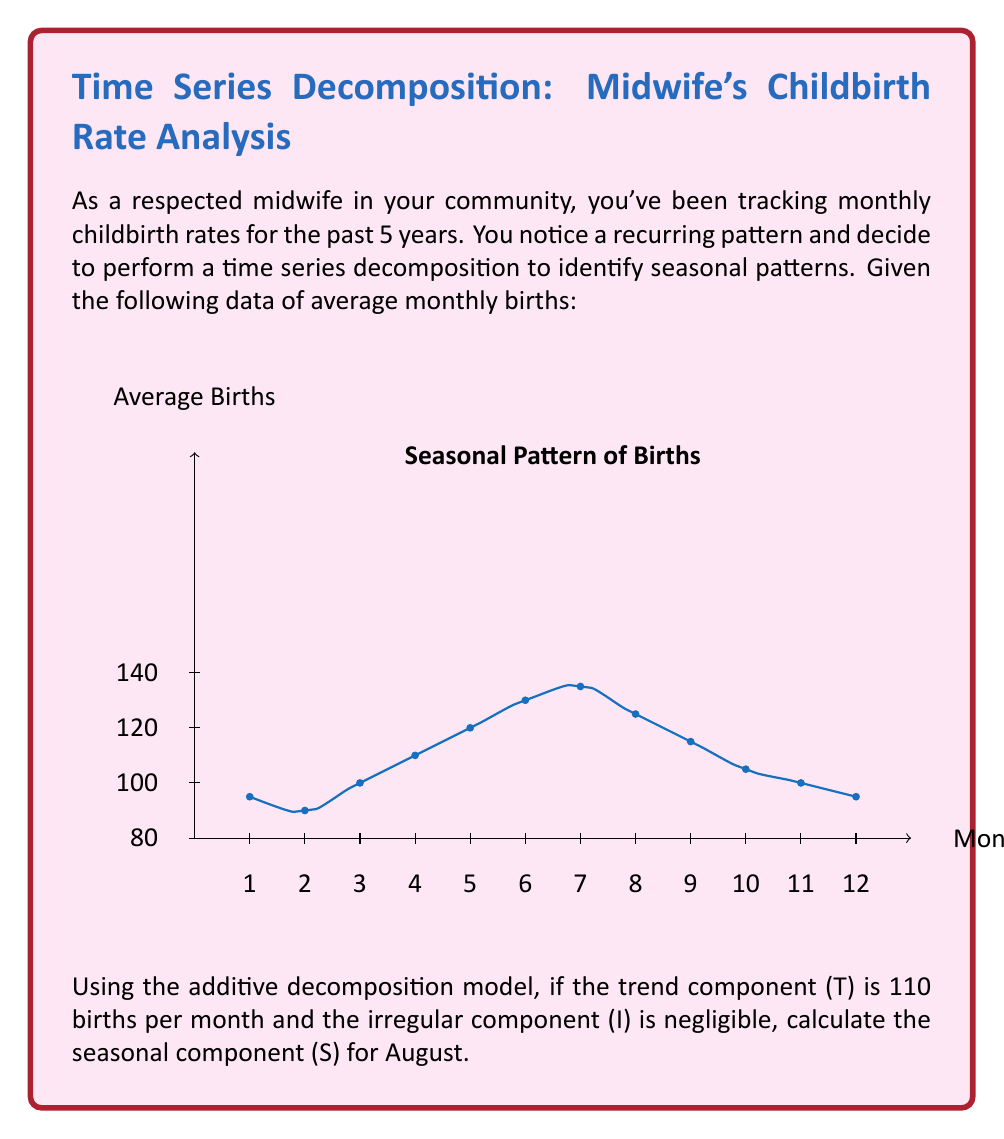What is the answer to this math problem? Let's approach this step-by-step using the additive decomposition model:

1) The additive decomposition model is represented as:
   $$Y = T + S + I$$
   Where Y is the observed value, T is the trend component, S is the seasonal component, and I is the irregular component.

2) We're given that the trend component (T) is 110 births per month and the irregular component (I) is negligible (we can assume it's 0).

3) From the graph, we can see that August (month 8) has an average of 125 births.

4) Substituting these values into our equation:
   $$125 = 110 + S + 0$$

5) Solving for S:
   $$S = 125 - 110 = 15$$

Therefore, the seasonal component (S) for August is 15 births above the trend.
Answer: 15 births 